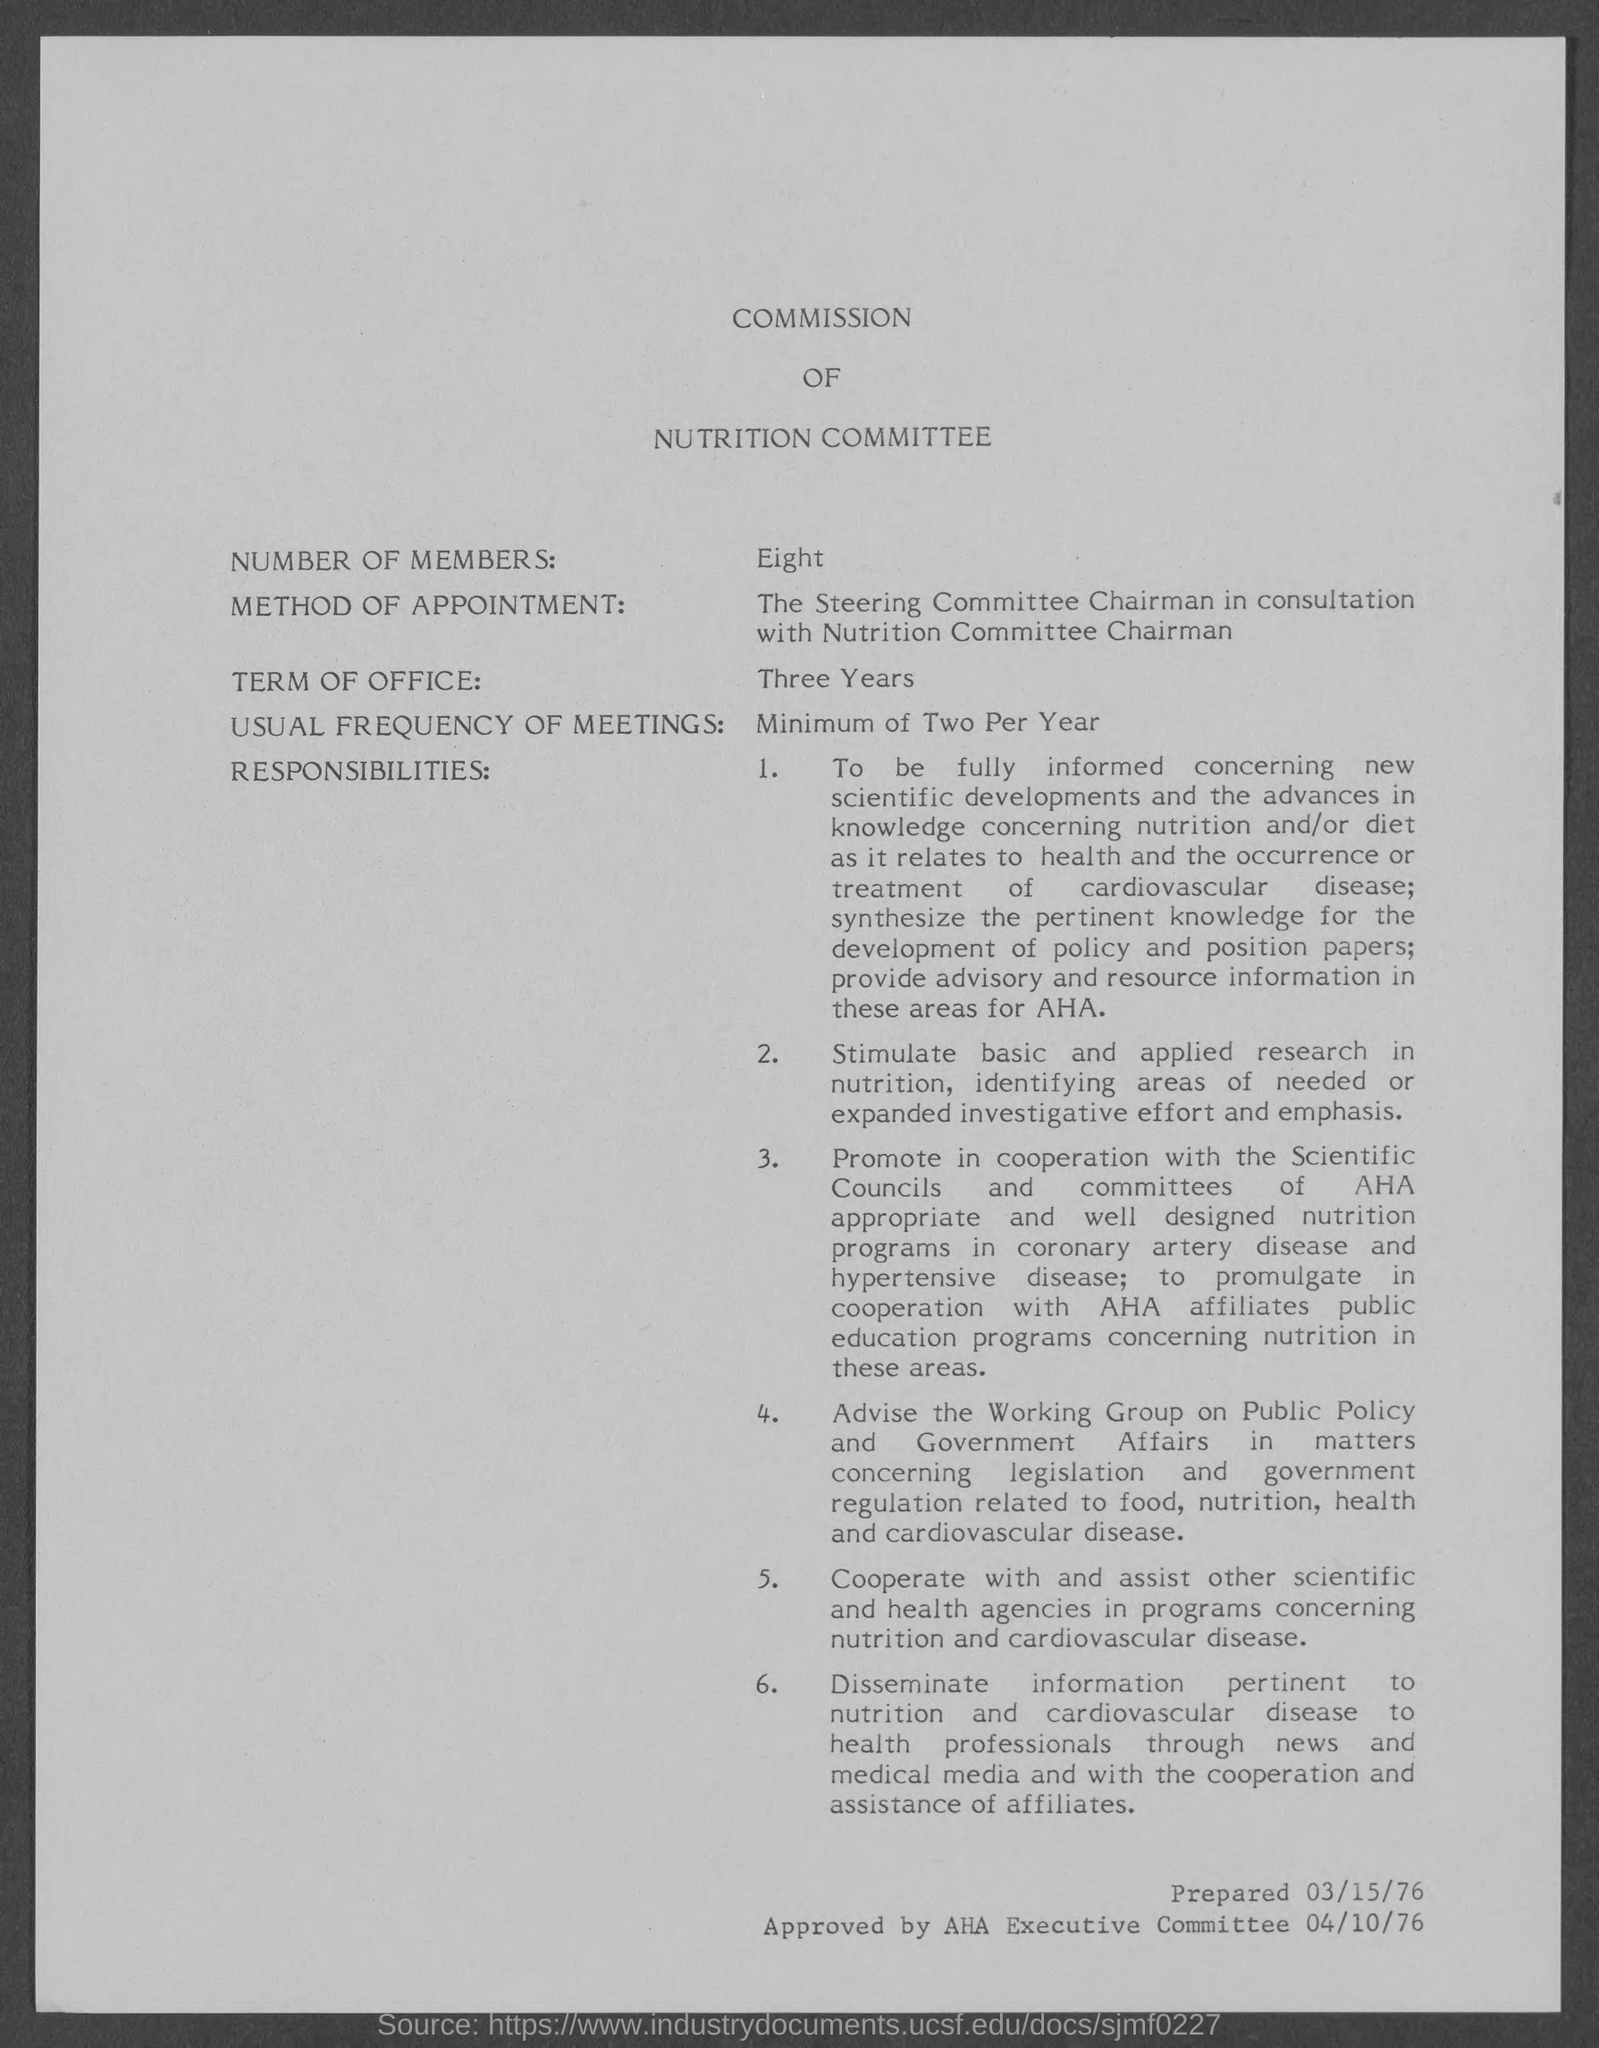Mention a couple of crucial points in this snapshot. It is customary to hold a minimum of two meetings per year. The term of office is three years. There are eight members. The document in question is titled 'Commission of Nutrition Committee.' On October 4th, 1976, the document was approved. 